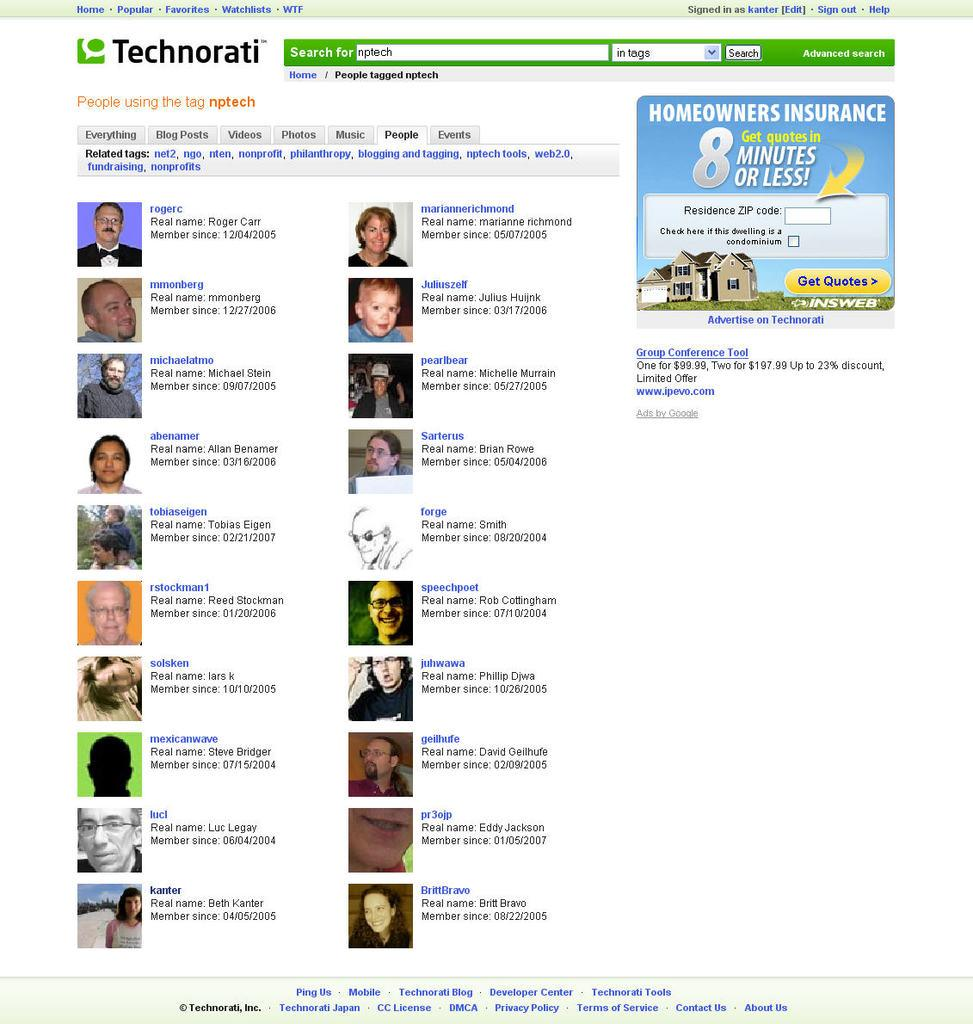What can be found in the image that contains written information? There is text in the image. What type of visuals are present in the image besides the text? There are photos of persons in the image. What type of structure is visible in the image? There is a house in the image. What color is the background of the image? The background of the image is white in color. What type of machine is visible in the image? There is no machine present in the image. How does the light affect the appearance of the persons in the image? There is no mention of light in the image, as the background is described as white in color. 